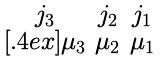Convert formula to latex. <formula><loc_0><loc_0><loc_500><loc_500>\begin{smallmatrix} j _ { 3 } & j _ { 2 } & j _ { 1 } \\ [ . 4 e x ] \mu _ { 3 } & \mu _ { 2 } & \mu _ { 1 } \end{smallmatrix}</formula> 